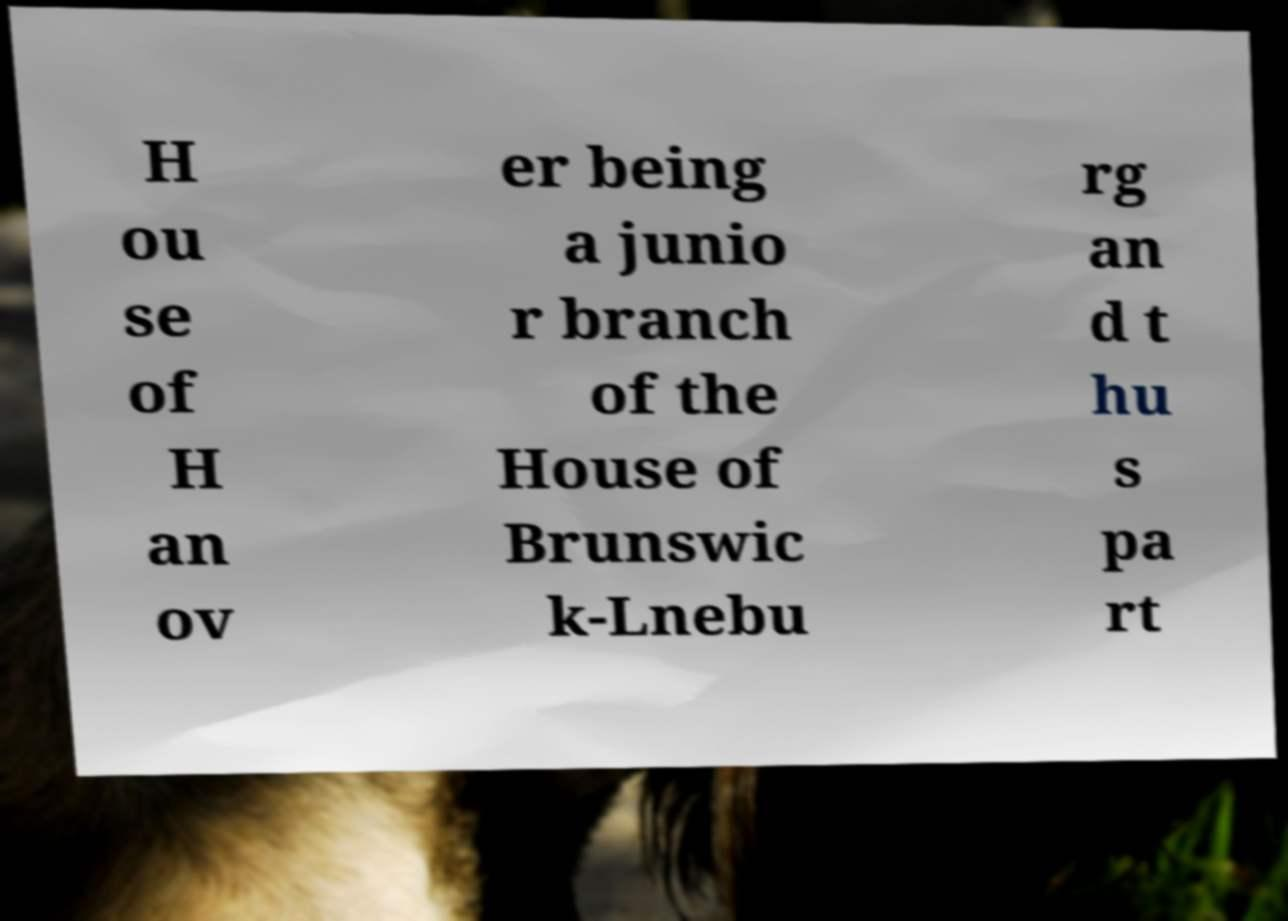There's text embedded in this image that I need extracted. Can you transcribe it verbatim? H ou se of H an ov er being a junio r branch of the House of Brunswic k-Lnebu rg an d t hu s pa rt 